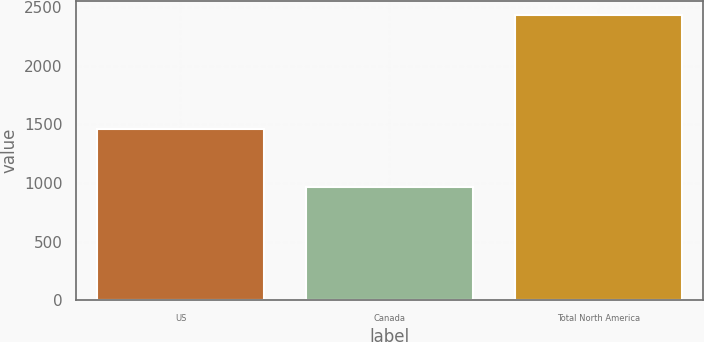Convert chart to OTSL. <chart><loc_0><loc_0><loc_500><loc_500><bar_chart><fcel>US<fcel>Canada<fcel>Total North America<nl><fcel>1463<fcel>967<fcel>2430<nl></chart> 